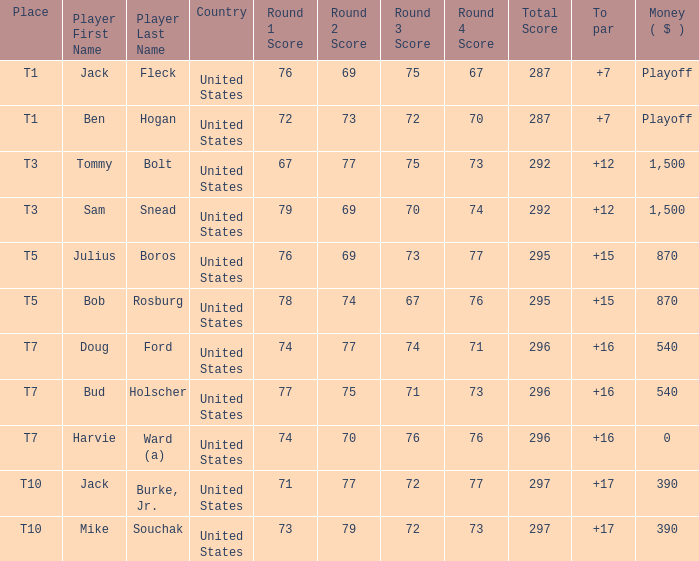Would you mind parsing the complete table? {'header': ['Place', 'Player First Name', 'Player Last Name', 'Country', 'Round 1 Score', 'Round 2 Score', 'Round 3 Score', 'Round 4 Score', 'Total Score', 'To par', 'Money ( $ )'], 'rows': [['T1', 'Jack', 'Fleck', 'United States', '76', '69', '75', '67', '287', '+7', 'Playoff'], ['T1', 'Ben', 'Hogan', 'United States', '72', '73', '72', '70', '287', '+7', 'Playoff'], ['T3', 'Tommy', 'Bolt', 'United States', '67', '77', '75', '73', '292', '+12', '1,500'], ['T3', 'Sam', 'Snead', 'United States', '79', '69', '70', '74', '292', '+12', '1,500'], ['T5', 'Julius', 'Boros', 'United States', '76', '69', '73', '77', '295', '+15', '870'], ['T5', 'Bob', 'Rosburg', 'United States', '78', '74', '67', '76', '295', '+15', '870'], ['T7', 'Doug', 'Ford', 'United States', '74', '77', '74', '71', '296', '+16', '540'], ['T7', 'Bud', 'Holscher', 'United States', '77', '75', '71', '73', '296', '+16', '540'], ['T7', 'Harvie', 'Ward (a)', 'United States', '74', '70', '76', '76', '296', '+16', '0'], ['T10', 'Jack', 'Burke, Jr.', 'United States', '71', '77', '72', '77', '297', '+17', '390'], ['T10', 'Mike', 'Souchak', 'United States', '73', '79', '72', '73', '297', '+17', '390']]} Which money has player Jack Fleck with t1 place? Playoff. 